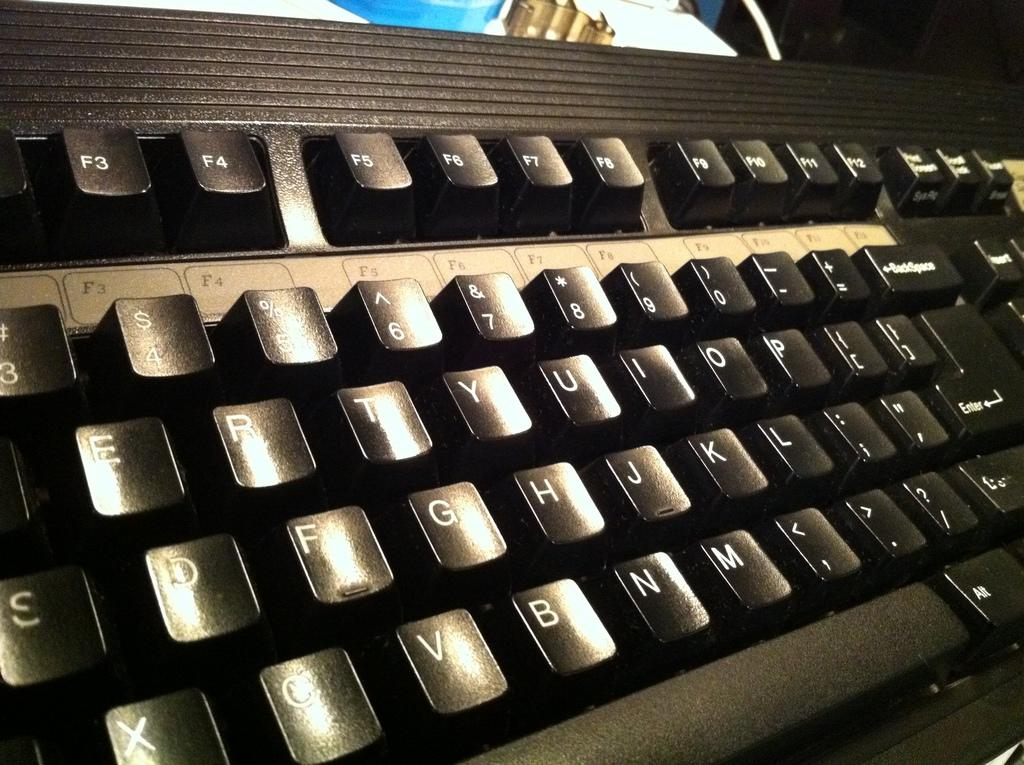<image>
Write a terse but informative summary of the picture. a close up of a black key board with keys for F4 and F5 